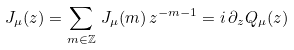<formula> <loc_0><loc_0><loc_500><loc_500>J _ { \mu } ( z ) = \sum _ { m \in { \mathbb { Z } } } \, J _ { \mu } ( m ) \, z ^ { - m - 1 } = i \, \partial _ { z } Q _ { \mu } ( z )</formula> 